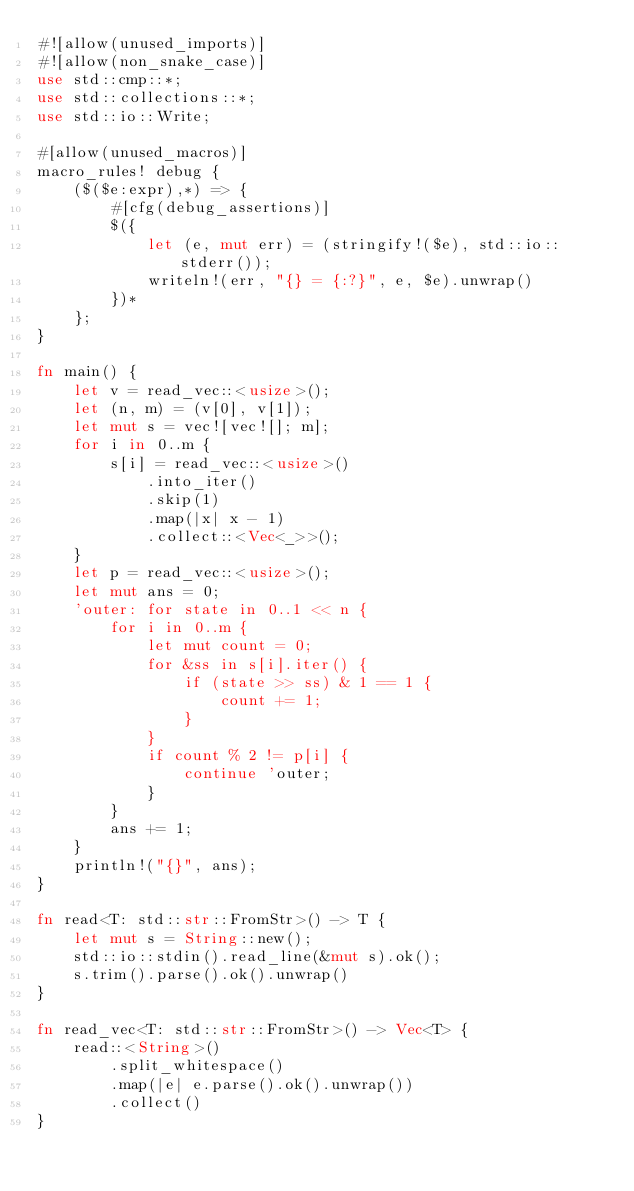<code> <loc_0><loc_0><loc_500><loc_500><_Rust_>#![allow(unused_imports)]
#![allow(non_snake_case)]
use std::cmp::*;
use std::collections::*;
use std::io::Write;

#[allow(unused_macros)]
macro_rules! debug {
    ($($e:expr),*) => {
        #[cfg(debug_assertions)]
        $({
            let (e, mut err) = (stringify!($e), std::io::stderr());
            writeln!(err, "{} = {:?}", e, $e).unwrap()
        })*
    };
}

fn main() {
    let v = read_vec::<usize>();
    let (n, m) = (v[0], v[1]);
    let mut s = vec![vec![]; m];
    for i in 0..m {
        s[i] = read_vec::<usize>()
            .into_iter()
            .skip(1)
            .map(|x| x - 1)
            .collect::<Vec<_>>();
    }
    let p = read_vec::<usize>();
    let mut ans = 0;
    'outer: for state in 0..1 << n {
        for i in 0..m {
            let mut count = 0;
            for &ss in s[i].iter() {
                if (state >> ss) & 1 == 1 {
                    count += 1;
                }
            }
            if count % 2 != p[i] {
                continue 'outer;
            }
        }
        ans += 1;
    }
    println!("{}", ans);
}

fn read<T: std::str::FromStr>() -> T {
    let mut s = String::new();
    std::io::stdin().read_line(&mut s).ok();
    s.trim().parse().ok().unwrap()
}

fn read_vec<T: std::str::FromStr>() -> Vec<T> {
    read::<String>()
        .split_whitespace()
        .map(|e| e.parse().ok().unwrap())
        .collect()
}
</code> 